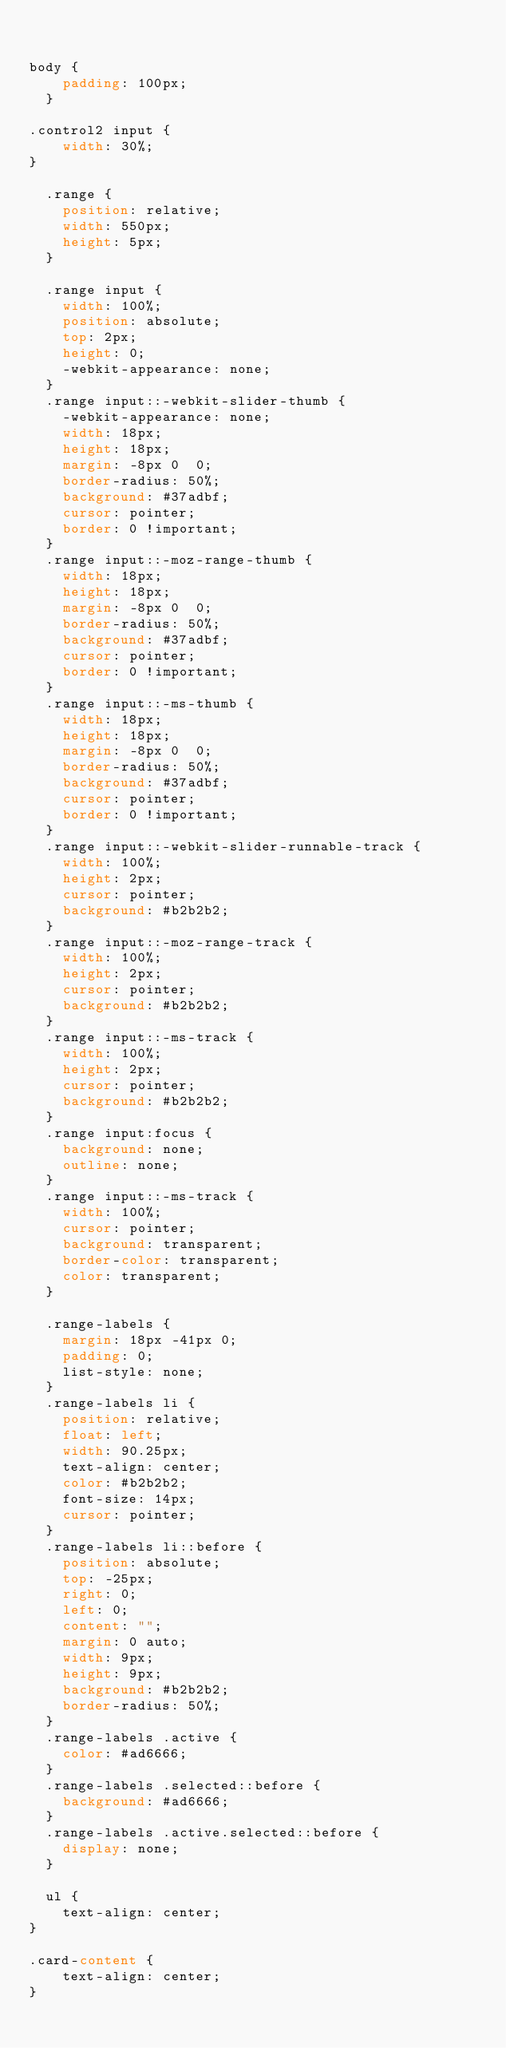Convert code to text. <code><loc_0><loc_0><loc_500><loc_500><_CSS_>

body {
    padding: 100px;
  }

.control2 input {
    width: 30%;
}

  .range {
    position: relative;
    width: 550px;
    height: 5px;
  }
  
  .range input {
    width: 100%;
    position: absolute;
    top: 2px;
    height: 0;
    -webkit-appearance: none;
  }
  .range input::-webkit-slider-thumb {
    -webkit-appearance: none;
    width: 18px;
    height: 18px;
    margin: -8px 0  0;
    border-radius: 50%;
    background: #37adbf;
    cursor: pointer;
    border: 0 !important;
  }
  .range input::-moz-range-thumb {
    width: 18px;
    height: 18px;
    margin: -8px 0  0;
    border-radius: 50%;
    background: #37adbf;
    cursor: pointer;
    border: 0 !important;
  }
  .range input::-ms-thumb {
    width: 18px;
    height: 18px;
    margin: -8px 0  0;
    border-radius: 50%;
    background: #37adbf;
    cursor: pointer;
    border: 0 !important;
  }
  .range input::-webkit-slider-runnable-track {
    width: 100%;
    height: 2px;
    cursor: pointer;
    background: #b2b2b2;
  }
  .range input::-moz-range-track {
    width: 100%;
    height: 2px;
    cursor: pointer;
    background: #b2b2b2;
  }
  .range input::-ms-track {
    width: 100%;
    height: 2px;
    cursor: pointer;
    background: #b2b2b2;
  }
  .range input:focus {
    background: none;
    outline: none;
  }
  .range input::-ms-track {
    width: 100%;
    cursor: pointer;
    background: transparent;
    border-color: transparent;
    color: transparent;
  }
  
  .range-labels {
    margin: 18px -41px 0;
    padding: 0;
    list-style: none;
  }
  .range-labels li {
    position: relative;
    float: left;
    width: 90.25px;
    text-align: center;
    color: #b2b2b2;
    font-size: 14px;
    cursor: pointer;
  }
  .range-labels li::before {
    position: absolute;
    top: -25px;
    right: 0;
    left: 0;
    content: "";
    margin: 0 auto;
    width: 9px;
    height: 9px;
    background: #b2b2b2;
    border-radius: 50%;
  }
  .range-labels .active {
    color: #ad6666;
  }
  .range-labels .selected::before {
    background: #ad6666;
  }
  .range-labels .active.selected::before {
    display: none;
  }

  ul {
    text-align: center;
}

.card-content {
    text-align: center;
}</code> 